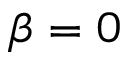Convert formula to latex. <formula><loc_0><loc_0><loc_500><loc_500>\beta = 0</formula> 